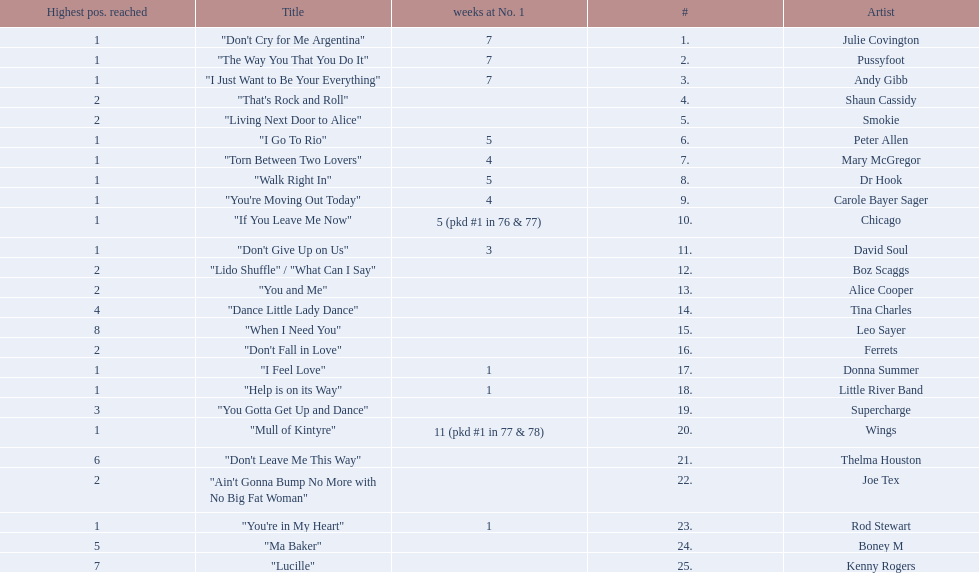Which song stayed at no.1 for the most amount of weeks. "Mull of Kintyre". 